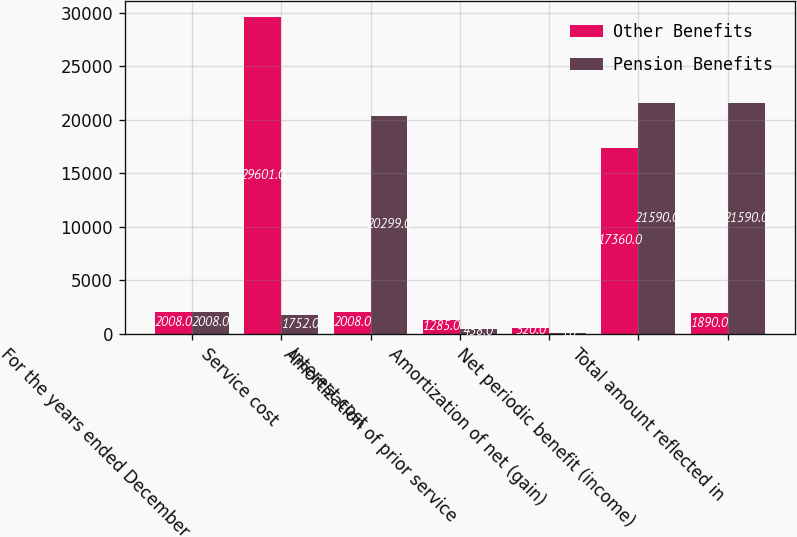<chart> <loc_0><loc_0><loc_500><loc_500><stacked_bar_chart><ecel><fcel>For the years ended December<fcel>Service cost<fcel>Interest cost<fcel>Amortization of prior service<fcel>Amortization of net (gain)<fcel>Net periodic benefit (income)<fcel>Total amount reflected in<nl><fcel>Other Benefits<fcel>2008<fcel>29601<fcel>2008<fcel>1285<fcel>520<fcel>17360<fcel>1890<nl><fcel>Pension Benefits<fcel>2008<fcel>1752<fcel>20299<fcel>458<fcel>3<fcel>21590<fcel>21590<nl></chart> 